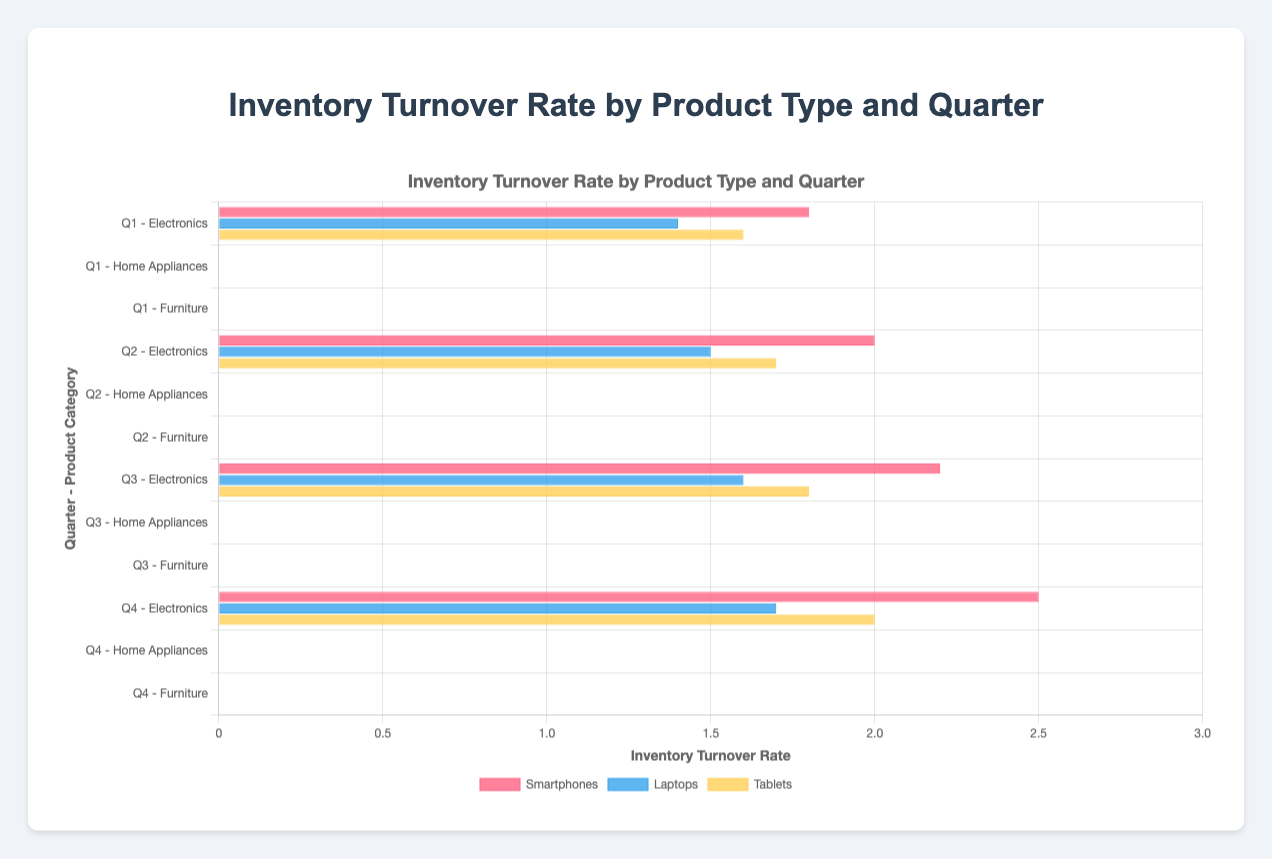How has the inventory turnover rate for "Smartphones" in "Electronics" changed from Q1 to Q4? The inventory turnover rate for "Smartphones" in "Electronics" has increased from 1.8 in Q1 to 2.5 in Q4
Answer: Turnover has increased Which product type in "Electronics" has the highest inventory turnover rate in Q4? Looking at the inventory turnover rates in Q4 for "Electronics", "Smartphones" has the highest rate at 2.5
Answer: Smartphones Compare the inventory turnover rates of "Refrigerators" and "Desks" in Q3. Which one is higher? In Q3, "Refrigerators" have an inventory turnover rate of 1.0, while "Desks" have a rate of 1.3. Therefore, "Desks" have a higher turnover rate
Answer: Desks What is the average inventory turnover rate for "Furniture" in Q2? The turnover rates for "Furniture" in Q2 are 1.2 (Desks), 1.6 (Chairs), and 1.1 (Tables). The average is calculated as (1.2 + 1.6 + 1.1) / 3 = 1.3
Answer: 1.3 How does the inventory turnover rate for "Microwaves" in "Home Appliances" visually compare across quarters? The inventory turnover rate for "Microwaves" increases steadily from Q1 to Q4: 1.2 in Q1, 1.3 in Q2, 1.4 in Q3, and 1.5 in Q4
Answer: Increases steadily Which product category in Q1 has the lowest inventory turnover rate and what is its value? In Q1, "Refrigerators" in "Home Appliances" have the lowest inventory turnover rate with a value of 0.8
Answer: Home Appliances, Refrigerators, 0.8 What has been the trend in inventory turnover rate for "Laptops" throughout the year? The inventory turnover rate for "Laptops" has shown a steady increase from 1.4 in Q1 to 1.7 in Q4
Answer: Increasing What is the combined inventory turnover rate for "Chairs" over the four quarters in "Furniture"? The turnover rates for "Chairs" in "Furniture" are 1.5 (Q1), 1.6 (Q2), 1.7 (Q3), and 1.8 (Q4). The combined total is 1.5 + 1.6 + 1.7 + 1.8 = 6.6
Answer: 6.6 Which product in "Home Appliances" has shown a consistent increase in inventory turnover rate from Q1 to Q4? "Microwaves" in "Home Appliances" have shown a consistent increase from 1.2 in Q1 to 1.5 in Q4
Answer: Microwaves Are there any products where the inventory turnover rate has remained the same between any quarters? If so, which ones? Yes, "Tables" in "Furniture" have the same turnover rate of 1.2 in both Q1 and Q2
Answer: Tables 